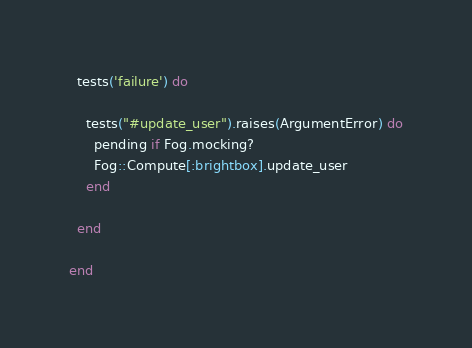Convert code to text. <code><loc_0><loc_0><loc_500><loc_500><_Ruby_>  tests('failure') do

    tests("#update_user").raises(ArgumentError) do
      pending if Fog.mocking?
      Fog::Compute[:brightbox].update_user
    end

  end

end
</code> 